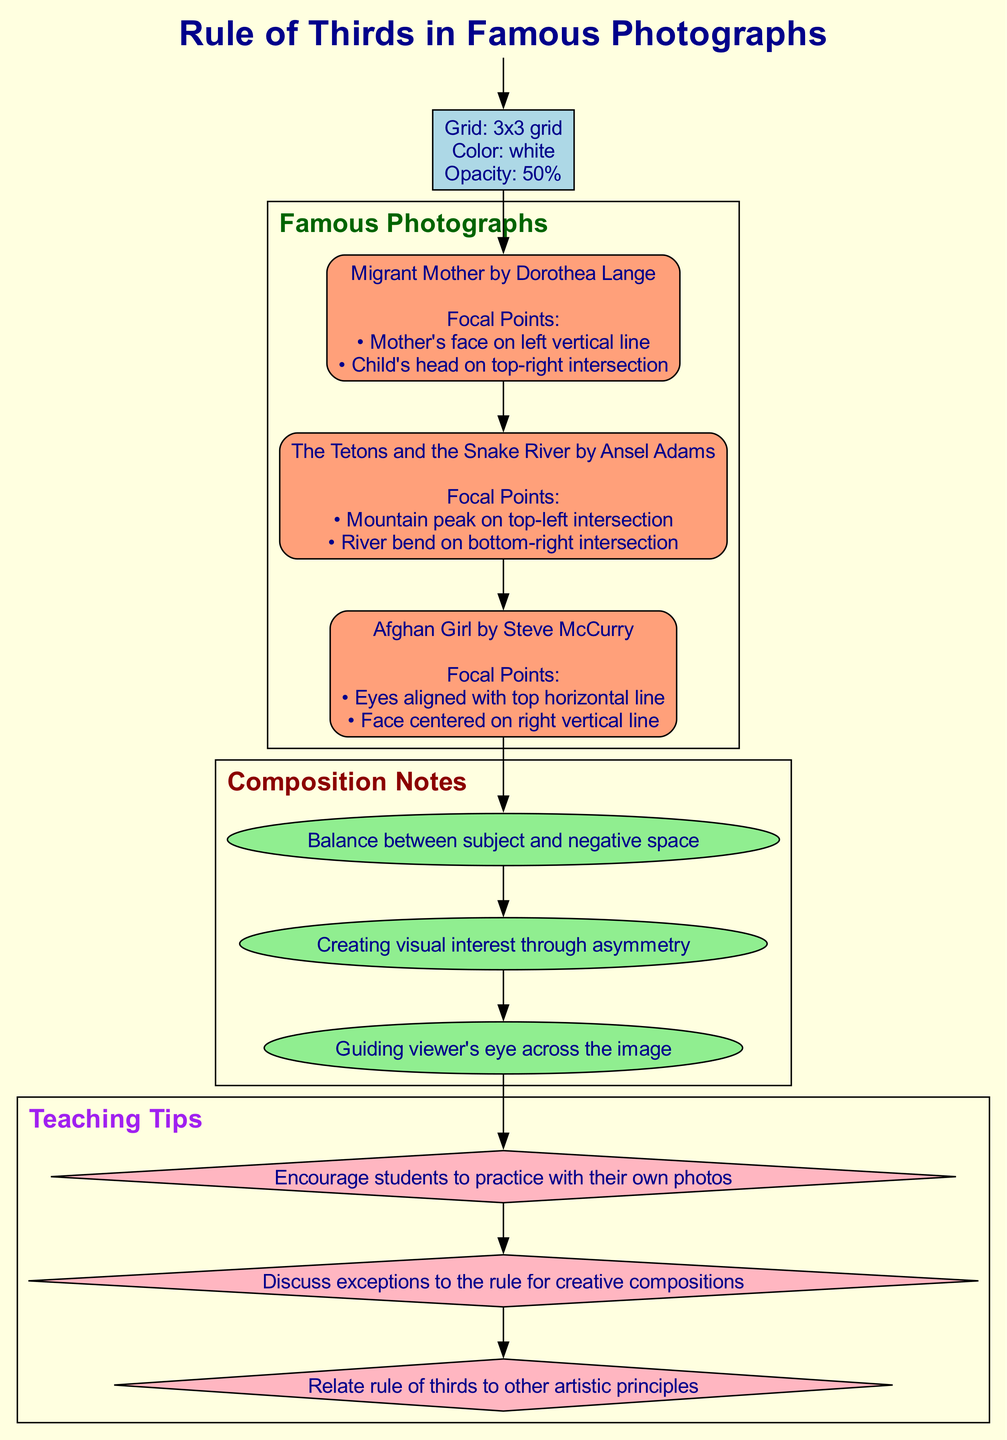What is the title of the diagram? The title information is included at the top of the diagram, clearly stated as "Rule of Thirds in Famous Photographs." This is the main heading that encapsulates the content of the diagram.
Answer: Rule of Thirds in Famous Photographs How many famous photographs are listed in the diagram? By counting the photographs represented in the diagram, we see that there are three specified under the "Famous Photographs" section. This includes "Migrant Mother," "The Tetons and the Snake River," and "Afghan Girl."
Answer: 3 What focal point is located on the left vertical line in "Migrant Mother"? In the description for "Migrant Mother," it explicitly states that the focal point is the "Mother's face on left vertical line." To find this, we refer to the list of focal points for this specific photograph.
Answer: Mother's face What composition note emphasizes visual interest? The diagram lists three composition notes, one of which states, "Creating visual interest through asymmetry." This note directly addresses the aspect of interest within photographic composition.
Answer: Creating visual interest through asymmetry Which photograph has its eyes aligned with the top horizontal line? Reviewing the focal points for the photographs, the description for "Afghan Girl" states that "Eyes aligned with top horizontal line" is one of its focal points. This identifies the focal point related to the specific horizontal alignment.
Answer: Afghan Girl What shape is used for the teaching tips in the diagram? Looking at the diagram, the teaching tips are represented in diamond-shaped nodes. The shape type is specified under the "Teaching Tips" section, which helps categorize the information visually.
Answer: Diamond Which photograph contains a mountain peak as a focal point? From the descriptions provided, "The Tetons and the Snake River" specifically mentions that the "Mountain peak on top-left intersection" serves as one of its focal points. This connects the photo title directly to a visual element.
Answer: The Tetons and the Snake River What is the color of the grid used in the diagram? The grid is described in the section that explains its properties, stating that the grid color is "white." This is part of the visual setup for presenting the rule of thirds.
Answer: White What is one of the teaching tips related to the rule of thirds? Among the teaching tips listed, one states, "Discuss exceptions to the rule for creative compositions." This suggests a viewpoint toward flexibility and creativity in applying the rule of thirds.
Answer: Discuss exceptions to the rule for creative compositions 